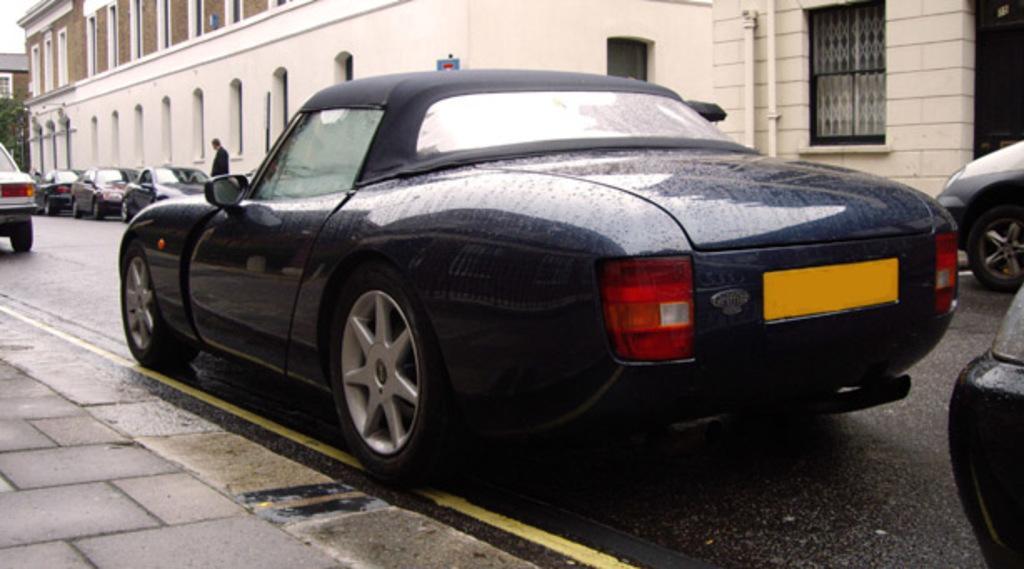How would you summarize this image in a sentence or two? In this image we can see vehicles on the road and a person is standing at the vehicle. On the left side at the bottom corner we can see the footpath. In the background there are buildings, windows, doors, poles, trees and sky. 